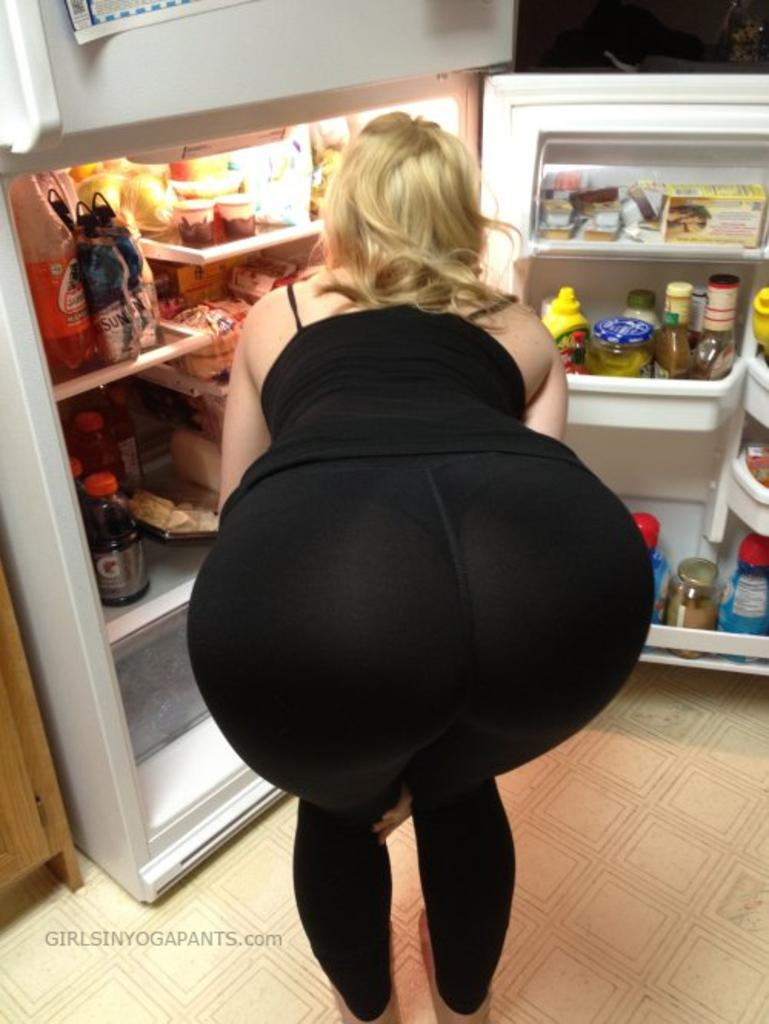What is the main subject of the image? There is a lady in the image. How is the lady positioned in the image? The lady is bent. What can be seen in the background of the image? There is a fridge in the background of the image. What is the state of the fridge in the image? The fridge is open. What items can be seen inside the fridge? There are bottles and food items inside the fridge. What is the lady wearing in the image? The lady is wearing a black dress. How much money is the lady holding in the image? There is no indication of money in the image; the lady is not holding any. 